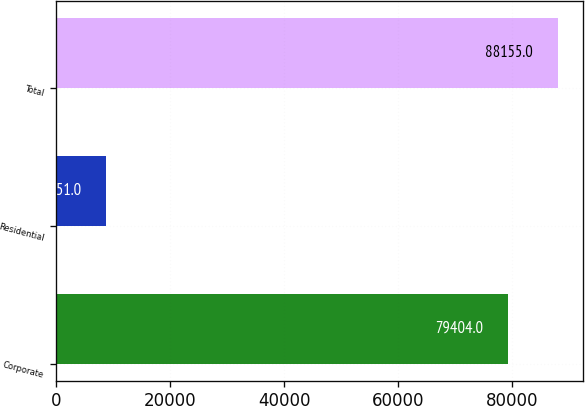Convert chart. <chart><loc_0><loc_0><loc_500><loc_500><bar_chart><fcel>Corporate<fcel>Residential<fcel>Total<nl><fcel>79404<fcel>8751<fcel>88155<nl></chart> 